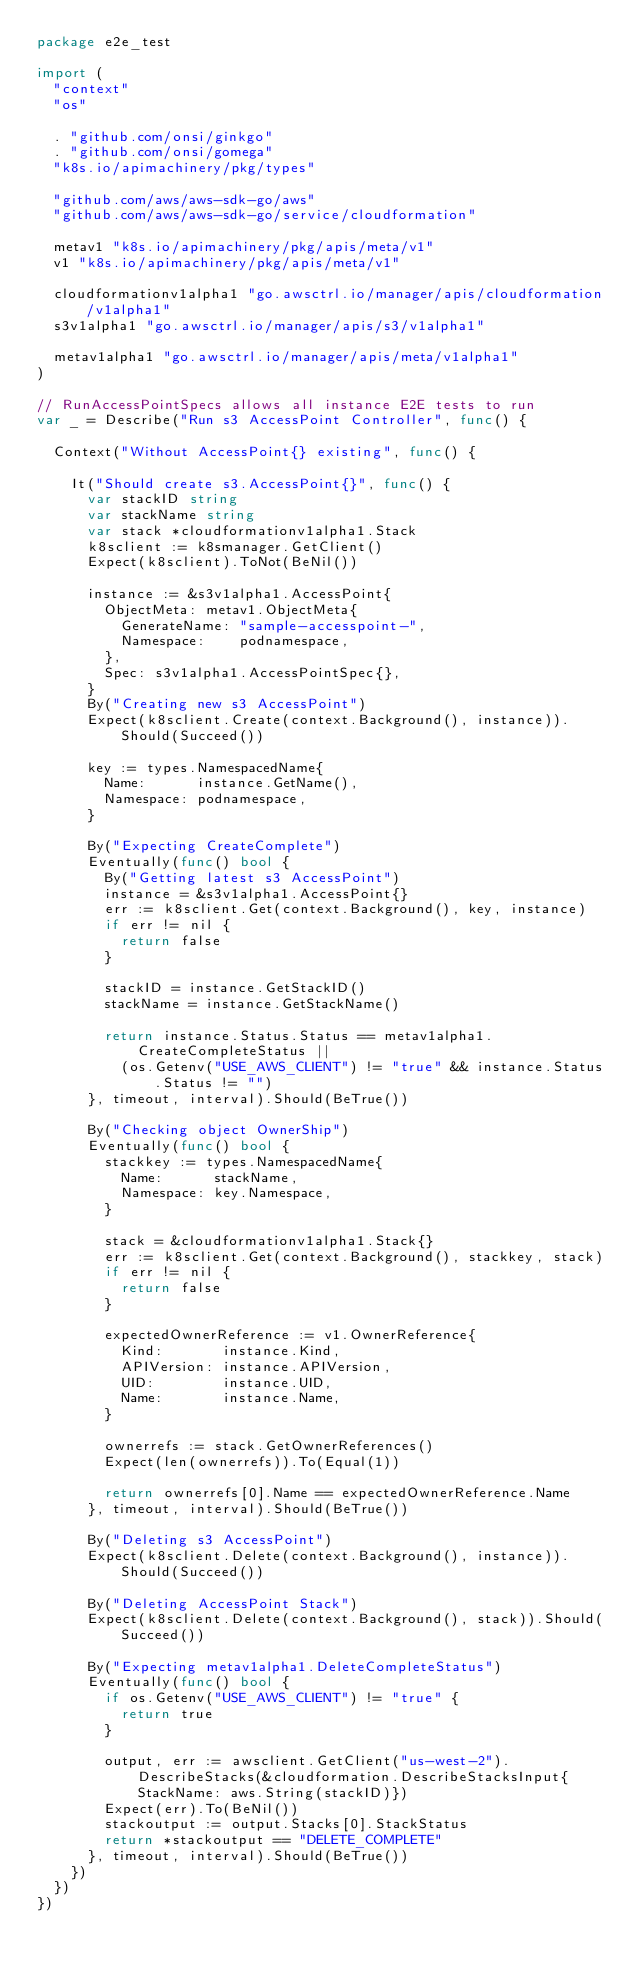<code> <loc_0><loc_0><loc_500><loc_500><_Go_>package e2e_test

import (
	"context"
	"os"

	. "github.com/onsi/ginkgo"
	. "github.com/onsi/gomega"
	"k8s.io/apimachinery/pkg/types"

	"github.com/aws/aws-sdk-go/aws"
	"github.com/aws/aws-sdk-go/service/cloudformation"

	metav1 "k8s.io/apimachinery/pkg/apis/meta/v1"
	v1 "k8s.io/apimachinery/pkg/apis/meta/v1"

	cloudformationv1alpha1 "go.awsctrl.io/manager/apis/cloudformation/v1alpha1"
	s3v1alpha1 "go.awsctrl.io/manager/apis/s3/v1alpha1"

	metav1alpha1 "go.awsctrl.io/manager/apis/meta/v1alpha1"
)

// RunAccessPointSpecs allows all instance E2E tests to run
var _ = Describe("Run s3 AccessPoint Controller", func() {

	Context("Without AccessPoint{} existing", func() {

		It("Should create s3.AccessPoint{}", func() {
			var stackID string
			var stackName string
			var stack *cloudformationv1alpha1.Stack
			k8sclient := k8smanager.GetClient()
			Expect(k8sclient).ToNot(BeNil())

			instance := &s3v1alpha1.AccessPoint{
				ObjectMeta: metav1.ObjectMeta{
					GenerateName: "sample-accesspoint-",
					Namespace:    podnamespace,
				},
				Spec: s3v1alpha1.AccessPointSpec{},
			}
			By("Creating new s3 AccessPoint")
			Expect(k8sclient.Create(context.Background(), instance)).Should(Succeed())

			key := types.NamespacedName{
				Name:      instance.GetName(),
				Namespace: podnamespace,
			}

			By("Expecting CreateComplete")
			Eventually(func() bool {
				By("Getting latest s3 AccessPoint")
				instance = &s3v1alpha1.AccessPoint{}
				err := k8sclient.Get(context.Background(), key, instance)
				if err != nil {
					return false
				}

				stackID = instance.GetStackID()
				stackName = instance.GetStackName()

				return instance.Status.Status == metav1alpha1.CreateCompleteStatus ||
					(os.Getenv("USE_AWS_CLIENT") != "true" && instance.Status.Status != "")
			}, timeout, interval).Should(BeTrue())

			By("Checking object OwnerShip")
			Eventually(func() bool {
				stackkey := types.NamespacedName{
					Name:      stackName,
					Namespace: key.Namespace,
				}

				stack = &cloudformationv1alpha1.Stack{}
				err := k8sclient.Get(context.Background(), stackkey, stack)
				if err != nil {
					return false
				}

				expectedOwnerReference := v1.OwnerReference{
					Kind:       instance.Kind,
					APIVersion: instance.APIVersion,
					UID:        instance.UID,
					Name:       instance.Name,
				}

				ownerrefs := stack.GetOwnerReferences()
				Expect(len(ownerrefs)).To(Equal(1))

				return ownerrefs[0].Name == expectedOwnerReference.Name
			}, timeout, interval).Should(BeTrue())

			By("Deleting s3 AccessPoint")
			Expect(k8sclient.Delete(context.Background(), instance)).Should(Succeed())

			By("Deleting AccessPoint Stack")
			Expect(k8sclient.Delete(context.Background(), stack)).Should(Succeed())

			By("Expecting metav1alpha1.DeleteCompleteStatus")
			Eventually(func() bool {
				if os.Getenv("USE_AWS_CLIENT") != "true" {
					return true
				}

				output, err := awsclient.GetClient("us-west-2").DescribeStacks(&cloudformation.DescribeStacksInput{StackName: aws.String(stackID)})
				Expect(err).To(BeNil())
				stackoutput := output.Stacks[0].StackStatus
				return *stackoutput == "DELETE_COMPLETE"
			}, timeout, interval).Should(BeTrue())
		})
	})
})
</code> 